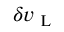<formula> <loc_0><loc_0><loc_500><loc_500>\delta v _ { L }</formula> 